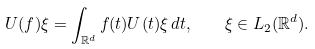Convert formula to latex. <formula><loc_0><loc_0><loc_500><loc_500>U ( f ) \xi = \int _ { { \mathbb { R } } ^ { d } } f ( t ) U ( t ) \xi \, d t , \quad \xi \in L _ { 2 } ( { \mathbb { R } } ^ { d } ) .</formula> 